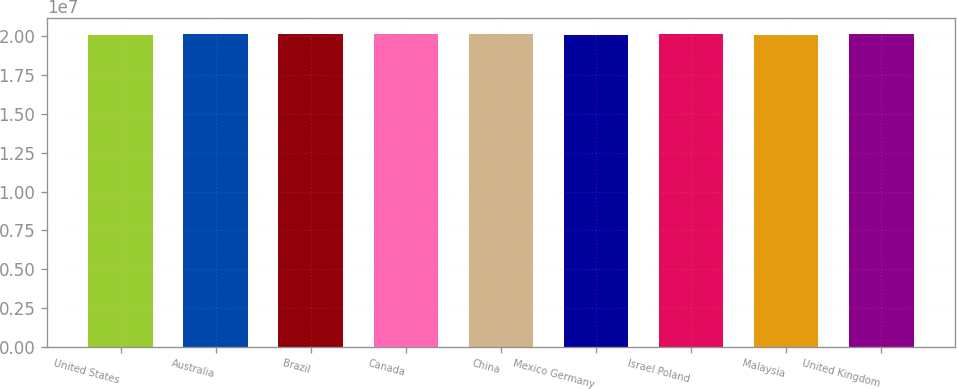Convert chart. <chart><loc_0><loc_0><loc_500><loc_500><bar_chart><fcel>United States<fcel>Australia<fcel>Brazil<fcel>Canada<fcel>China<fcel>Mexico Germany<fcel>Israel Poland<fcel>Malaysia<fcel>United Kingdom<nl><fcel>2.0082e+07<fcel>2.0148e+07<fcel>2.0132e+07<fcel>2.0156e+07<fcel>2.014e+07<fcel>2.0122e+07<fcel>2.0164e+07<fcel>2.0102e+07<fcel>2.0172e+07<nl></chart> 